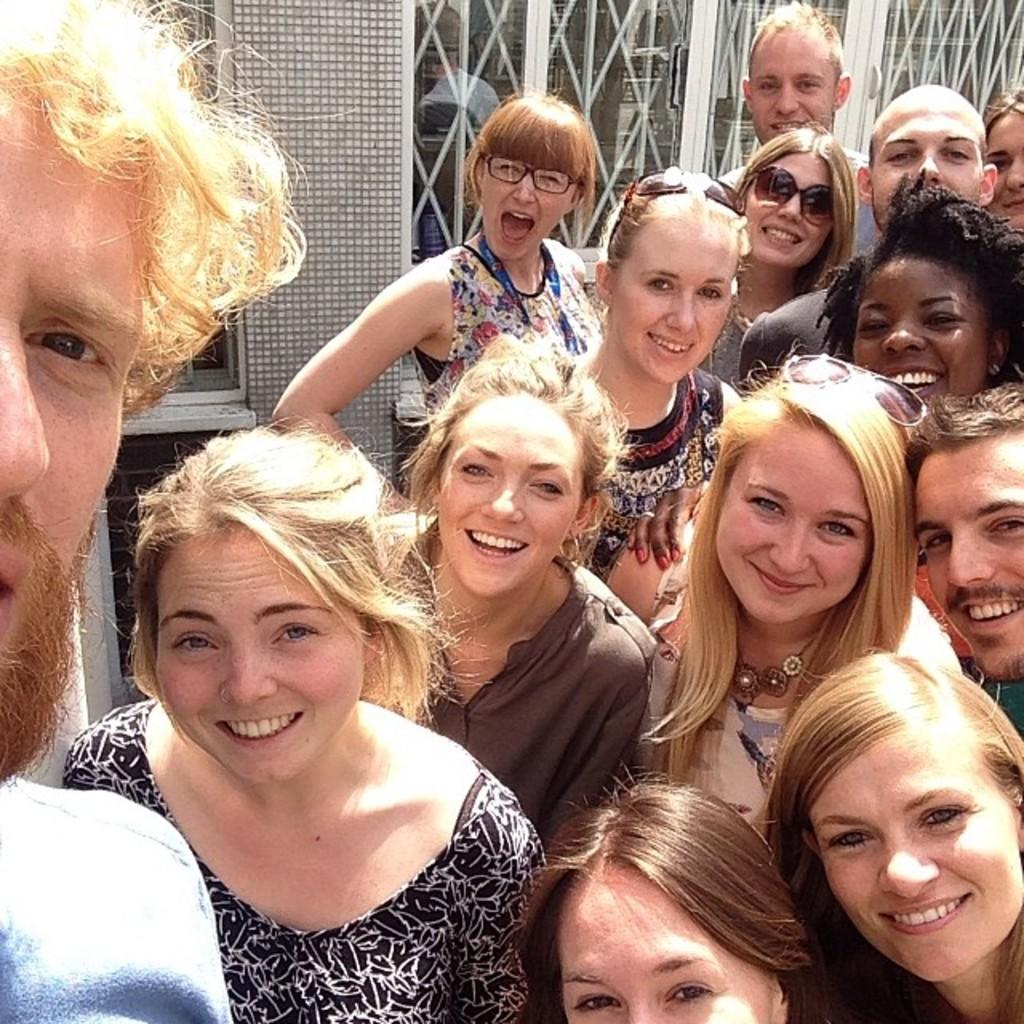What is the main subject of the image? The main subject of the image is a group of women. Where are the women located in the image? The women are standing on a path in the image. What is the facial expression of the women? The women are smiling in the image. Who else is present in the image? There is a man in the image. What is the man doing in the image? The man is capturing a selfie with the women. What can be seen in the background of the image? There is a wall with windows in the background of the image. What type of stitch is being used to repair the man's shirt in the image? There is no indication in the image that the man's shirt is being repaired, nor is there any visible stitching. Is there a fight occurring between the women in the image? No, the women are smiling and there is no indication of a fight in the image. 